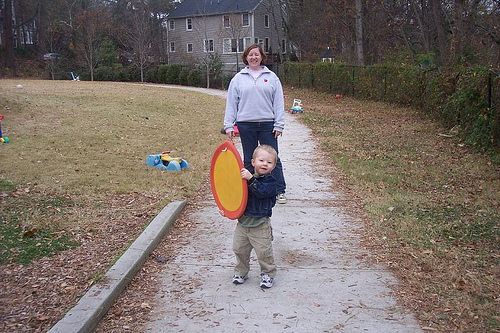<image>
Is the child behind the woman? No. The child is not behind the woman. From this viewpoint, the child appears to be positioned elsewhere in the scene. 